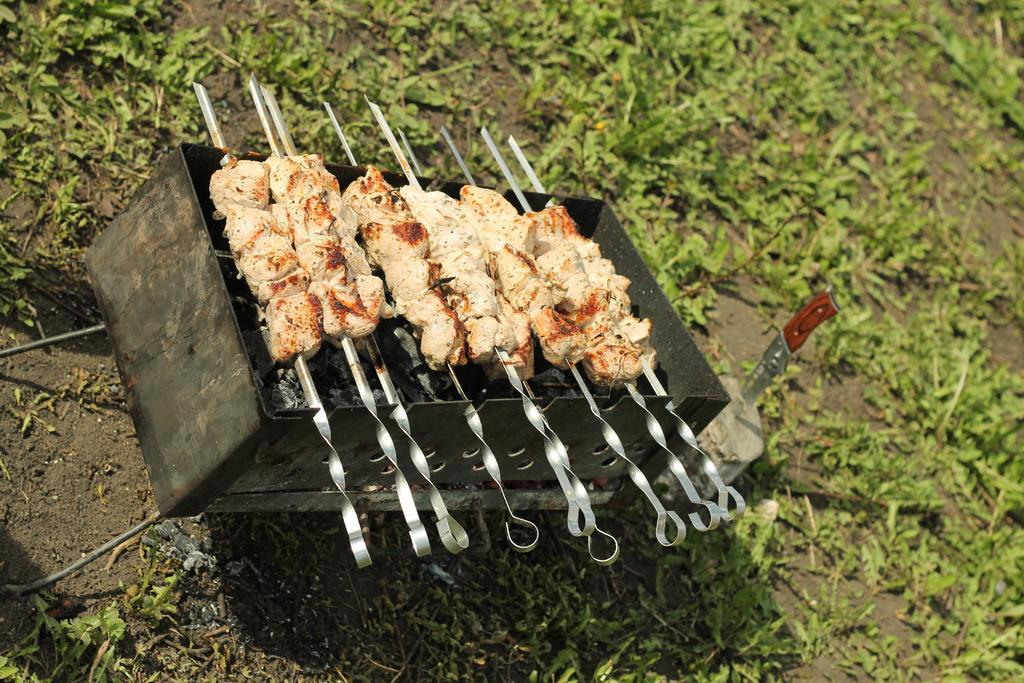Please provide a concise description of this image. In this picture we can see a grill and on the grill there are some food items, chrome plated BBQ meat skewers. Behind the grill there are plants. On the right side of the girl there is a knife on an object. 